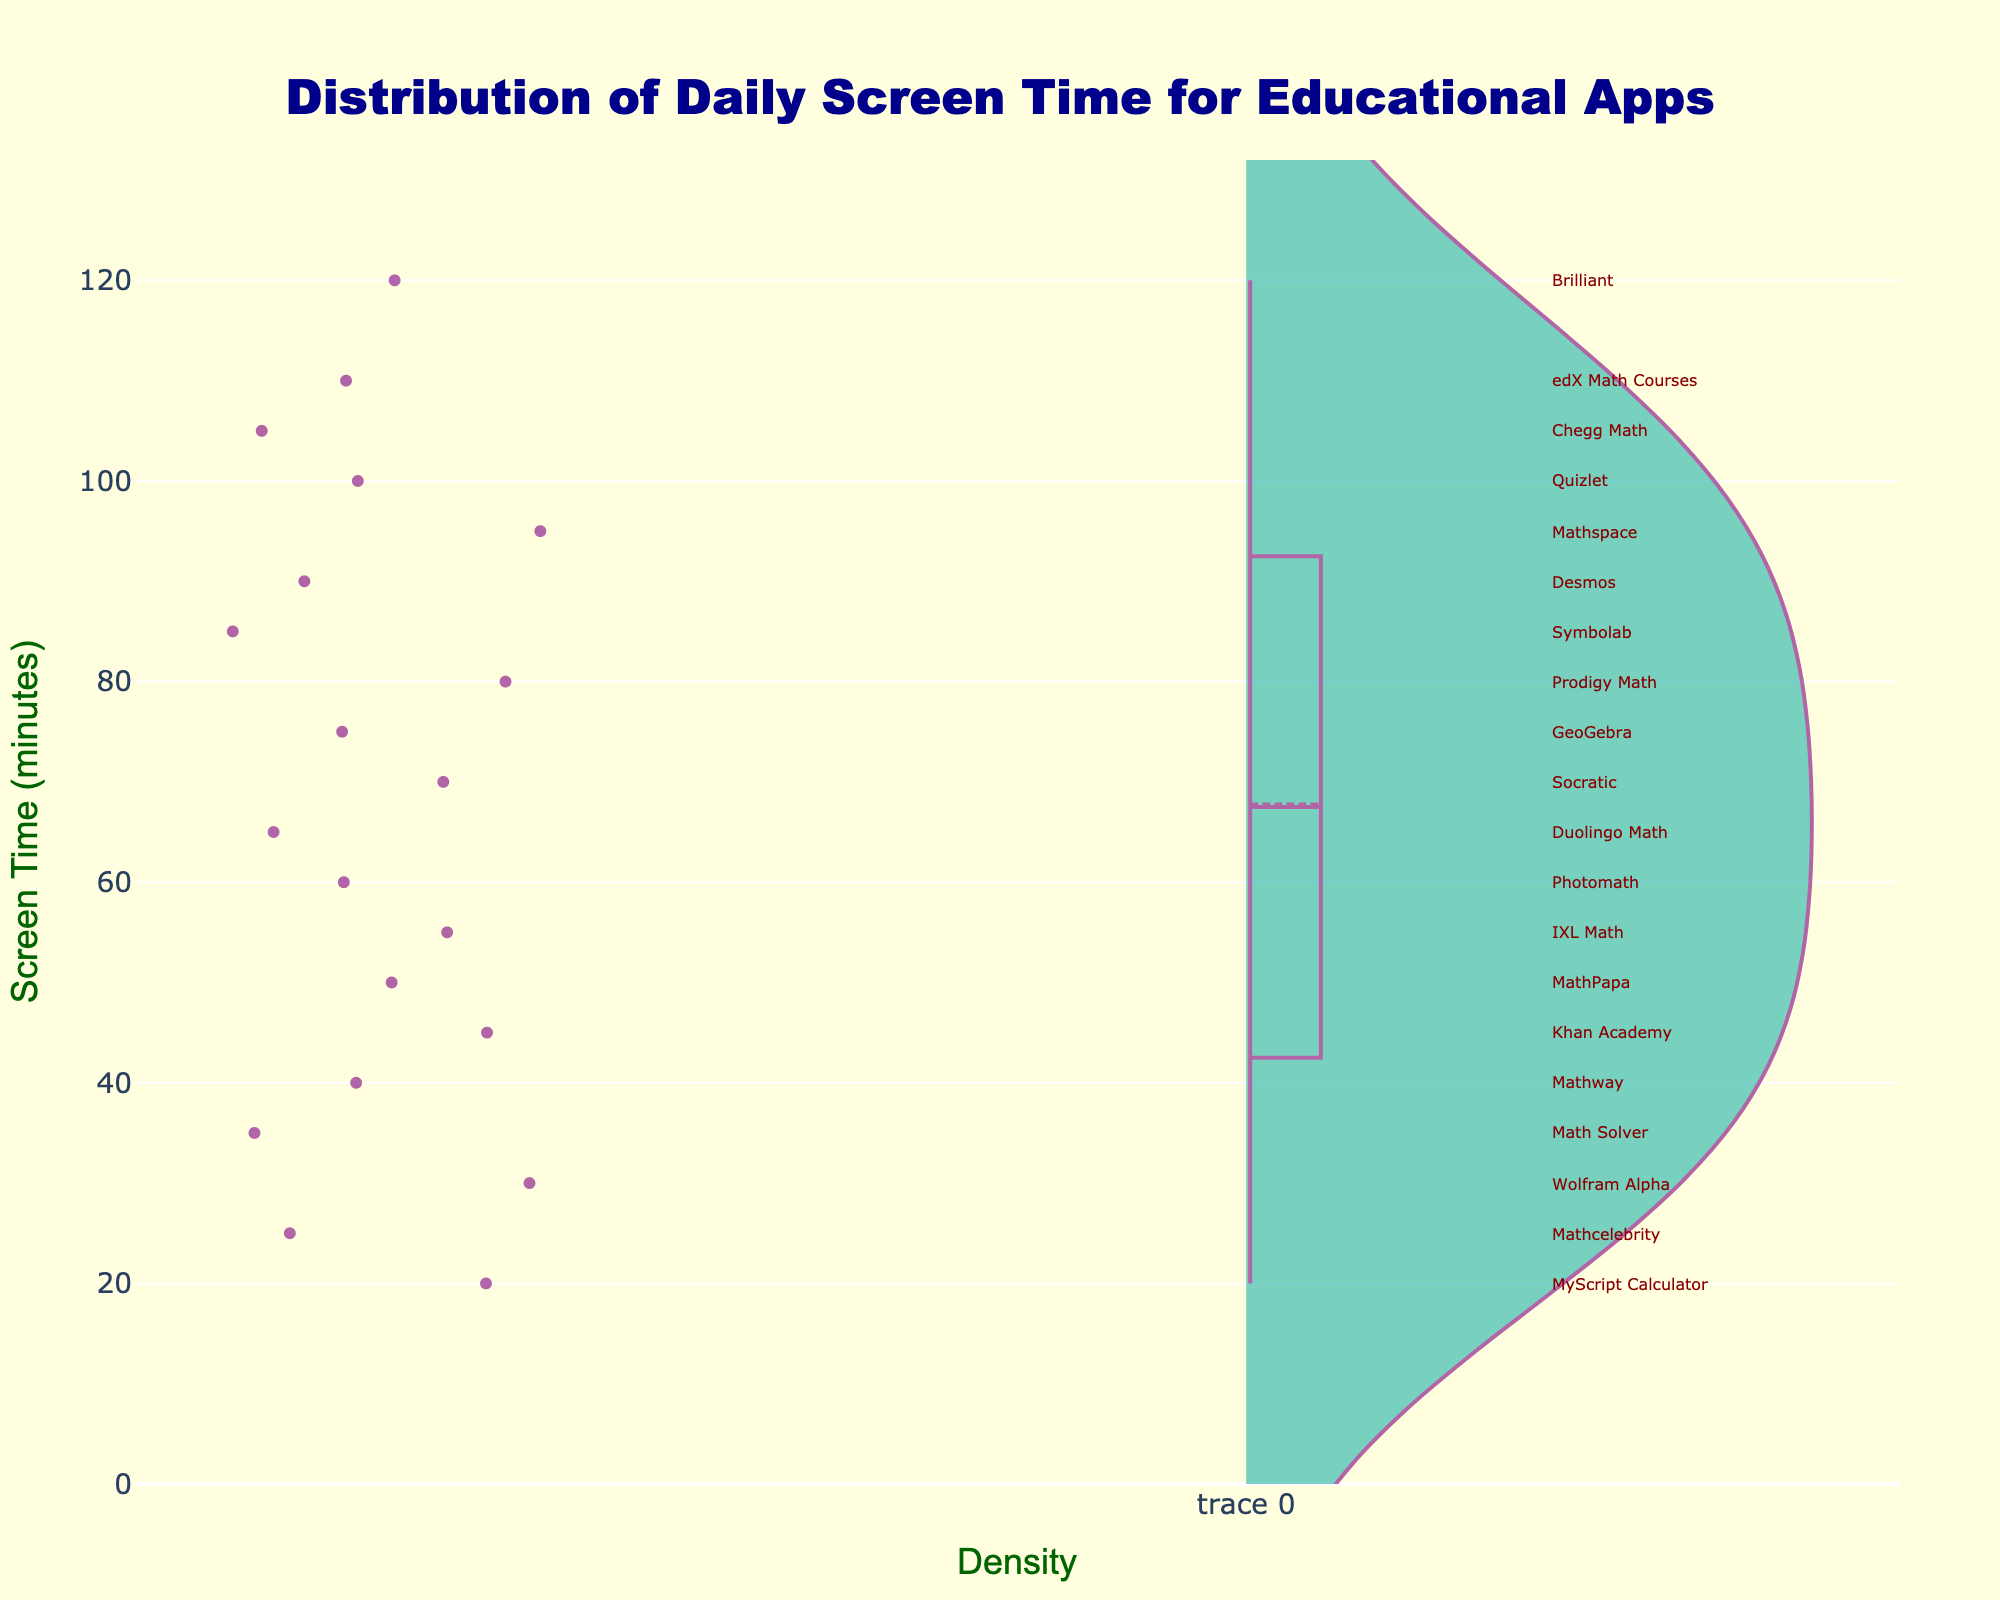What is the title of the density plot? The title of the density plot is found at the top of the figure, formatted in a larger and bolder font compared to the rest of the text. It provides an overview of what the plot represents.
Answer: Distribution of Daily Screen Time for Educational Apps What is the color of the box outline in the violin plot? The color of the box outline is specified by its distinct hue, which helps in distinguishing it from the fill color and the rest of the plot elements.
Answer: Purple What is the highest screen time recorded among the educational apps? To find the highest screen time, look at the topmost point of the violin plot, which represents the maximum value in the dataset.
Answer: 120 minutes What is the average screen time usage for the apps? Average is calculated by summing up all the screen times and dividing by the number of data points. Adding the screen times: 45 + 60 + 30 + 90 + 120 + 75 + 40 + 55 + 85 + 100 + 65 + 50 + 70 + 95 + 80 + 35 + 110 + 25 + 105 + 20 = 1275, then dividing by 20 apps: 1275 / 20 = 63.75.
Answer: 63.75 minutes Which app has the lowest screen time, and what is it? The lowest screen time is found at the bottom of the violin plot. By checking the annotation at the lowest point, we can identify the app.
Answer: MyScript Calculator, 20 minutes How many apps have a screen time of more than 100 minutes? To determine the number of apps with screen times over 100 minutes, observe all points above the 100-minute mark and count the corresponding annotations.
Answer: 4 apps Which app is used for exactly 55 minutes? Identify the annotation located at the 55-minute mark on the y-axis of the plot.
Answer: IXL Math Compare the screen times of Duolingo Math and Mathspace. Which one has a higher screen time and by how many minutes? Look at the annotations for Duolingo Math and Mathspace to find their screen times. Duolingo Math: 65 minutes, Mathspace: 95 minutes. Calculate the difference: 95 - 65 = 30.
Answer: Mathspace, by 30 minutes What is the median screen time of these apps? To find the median, list all screen times in ascending order and find the middle value. Since there are 20 data points, the median is the average of the 10th and 11th values. Sorted times: 20, 25, 30, 35, 40, 45, 50, 55, 60, 65, 70, 75, 80, 85, 90, 95, 100, 105, 110, 120. Median = (65 + 70) / 2 = 67.5.
Answer: 67.5 minutes What is the range of the screen time usage of the apps? The range is the difference between the maximum and minimum screen times. Maximum is 120 minutes, minimum is 20 minutes. Calculate: 120 - 20 = 100.
Answer: 100 minutes 